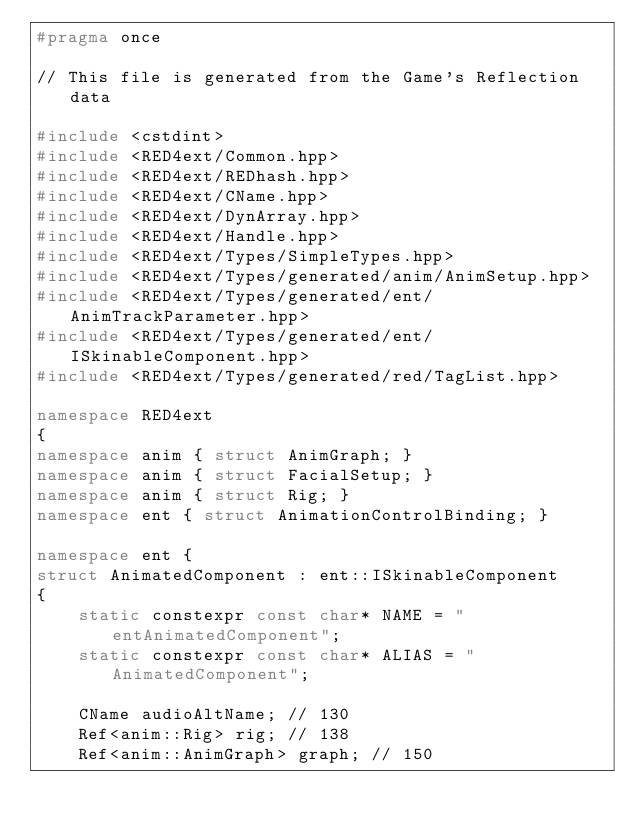<code> <loc_0><loc_0><loc_500><loc_500><_C++_>#pragma once

// This file is generated from the Game's Reflection data

#include <cstdint>
#include <RED4ext/Common.hpp>
#include <RED4ext/REDhash.hpp>
#include <RED4ext/CName.hpp>
#include <RED4ext/DynArray.hpp>
#include <RED4ext/Handle.hpp>
#include <RED4ext/Types/SimpleTypes.hpp>
#include <RED4ext/Types/generated/anim/AnimSetup.hpp>
#include <RED4ext/Types/generated/ent/AnimTrackParameter.hpp>
#include <RED4ext/Types/generated/ent/ISkinableComponent.hpp>
#include <RED4ext/Types/generated/red/TagList.hpp>

namespace RED4ext
{
namespace anim { struct AnimGraph; }
namespace anim { struct FacialSetup; }
namespace anim { struct Rig; }
namespace ent { struct AnimationControlBinding; }

namespace ent { 
struct AnimatedComponent : ent::ISkinableComponent
{
    static constexpr const char* NAME = "entAnimatedComponent";
    static constexpr const char* ALIAS = "AnimatedComponent";

    CName audioAltName; // 130
    Ref<anim::Rig> rig; // 138
    Ref<anim::AnimGraph> graph; // 150</code> 